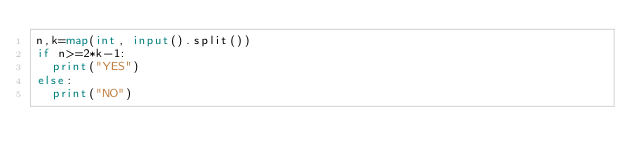Convert code to text. <code><loc_0><loc_0><loc_500><loc_500><_Python_>n,k=map(int, input().split())
if n>=2*k-1:
  print("YES")
else:
  print("NO")</code> 